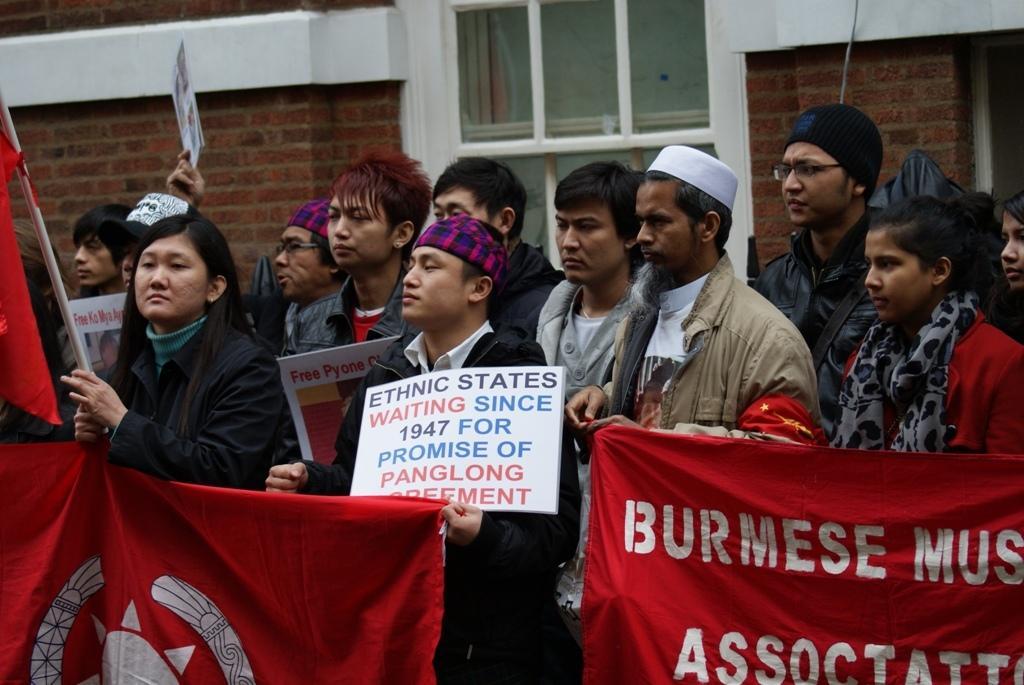In one or two sentences, can you explain what this image depicts? In this image there is a few people holding posters and banners, behind them there is a wall and a window. 